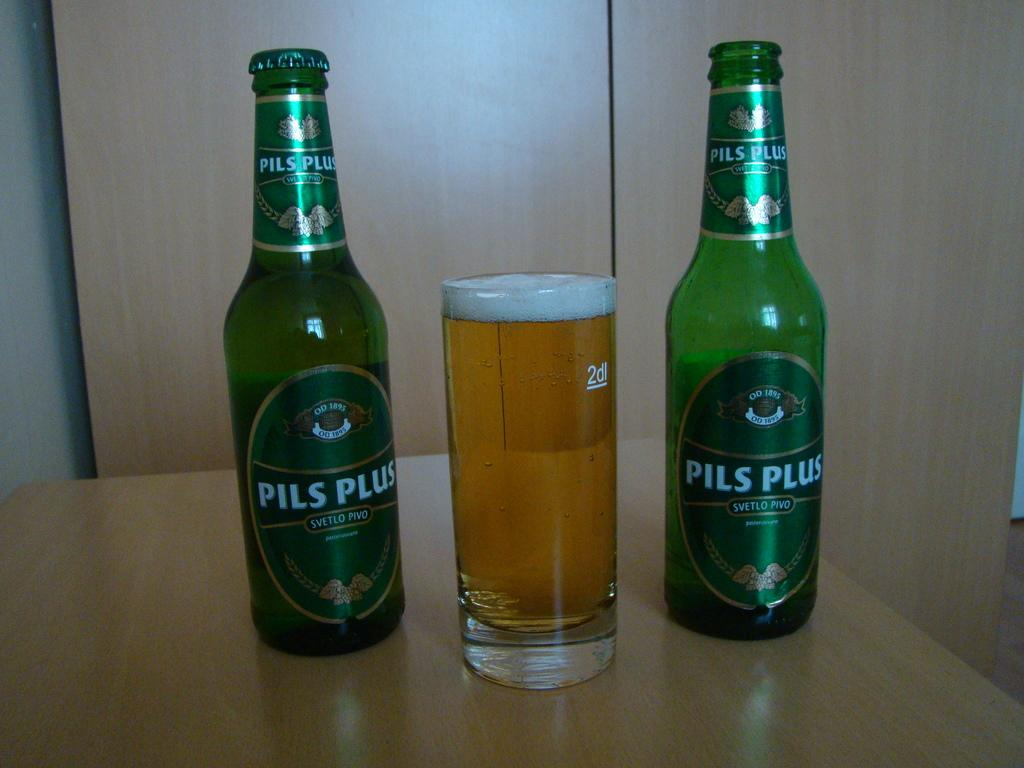<image>
Relay a brief, clear account of the picture shown. Two green bottles of Pils Plus are on either side of a stein of beer. 